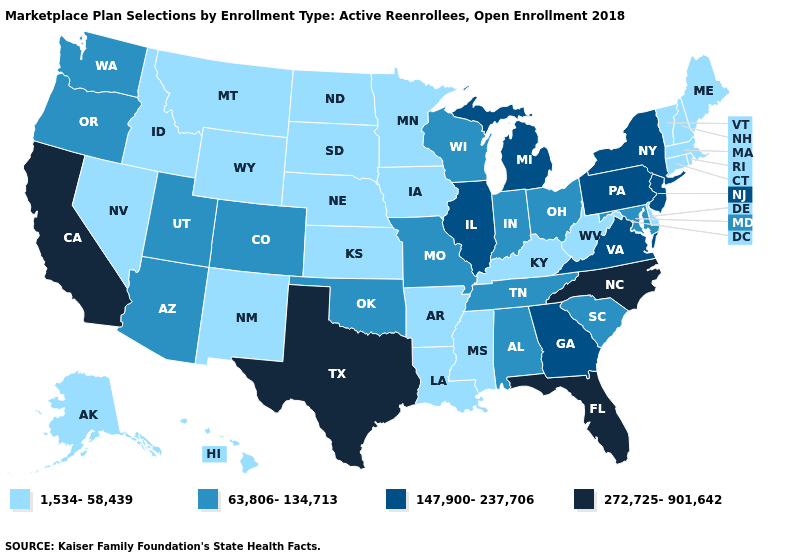Which states have the highest value in the USA?
Write a very short answer. California, Florida, North Carolina, Texas. What is the value of Illinois?
Short answer required. 147,900-237,706. Name the states that have a value in the range 272,725-901,642?
Write a very short answer. California, Florida, North Carolina, Texas. What is the highest value in the Northeast ?
Quick response, please. 147,900-237,706. What is the lowest value in the West?
Give a very brief answer. 1,534-58,439. Does Kansas have the same value as South Dakota?
Be succinct. Yes. Which states have the lowest value in the South?
Write a very short answer. Arkansas, Delaware, Kentucky, Louisiana, Mississippi, West Virginia. Among the states that border Pennsylvania , does New Jersey have the highest value?
Keep it brief. Yes. Among the states that border Utah , which have the lowest value?
Give a very brief answer. Idaho, Nevada, New Mexico, Wyoming. Name the states that have a value in the range 272,725-901,642?
Give a very brief answer. California, Florida, North Carolina, Texas. What is the highest value in states that border Kansas?
Concise answer only. 63,806-134,713. Among the states that border Oklahoma , does Kansas have the lowest value?
Write a very short answer. Yes. What is the lowest value in states that border Idaho?
Short answer required. 1,534-58,439. Does Kansas have the lowest value in the MidWest?
Answer briefly. Yes. Which states hav the highest value in the Northeast?
Write a very short answer. New Jersey, New York, Pennsylvania. 